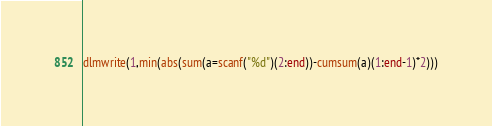<code> <loc_0><loc_0><loc_500><loc_500><_Octave_>dlmwrite(1,min(abs(sum(a=scanf("%d")(2:end))-cumsum(a)(1:end-1)*2)))</code> 